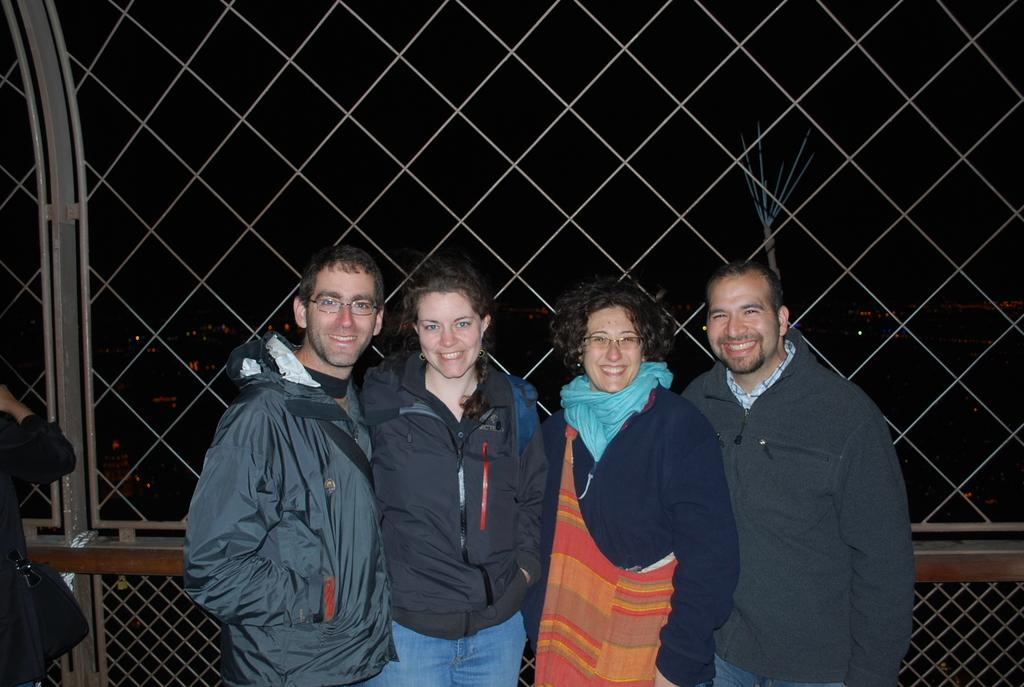What can be seen in the foreground of the image? There are people standing in the front of the image. What is the barrier between the people and the background? There is a fence in the image. How would you describe the lighting in the image? The background of the image is dark. What color are the eyes of the seashore in the image? There is no seashore present in the image, and therefore no eyes to describe. 